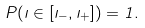Convert formula to latex. <formula><loc_0><loc_0><loc_500><loc_500>P ( \zeta \in [ \zeta _ { - } , \zeta _ { + } ] ) = 1 .</formula> 